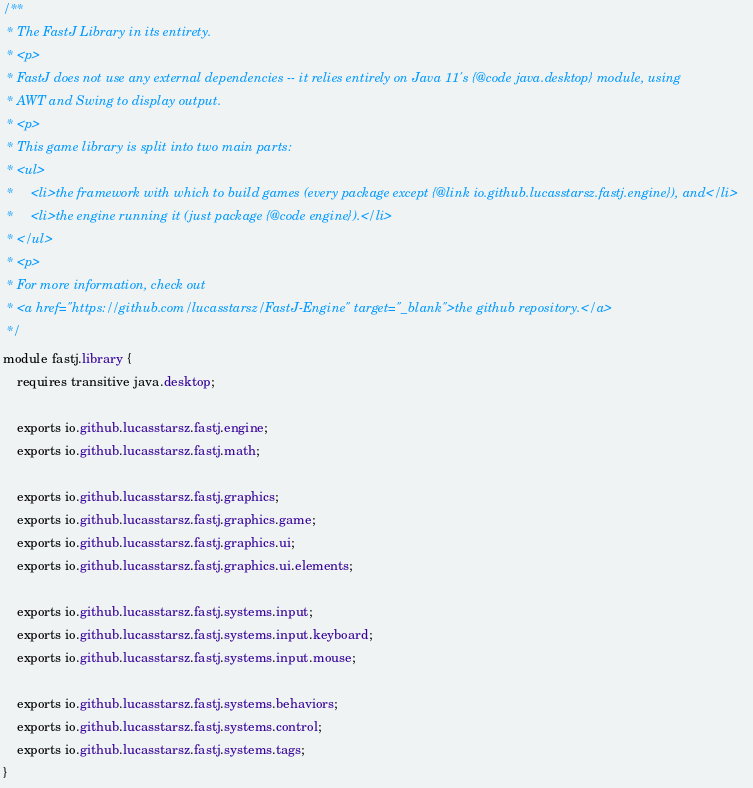<code> <loc_0><loc_0><loc_500><loc_500><_Java_>/**
 * The FastJ Library in its entirety.
 * <p>
 * FastJ does not use any external dependencies -- it relies entirely on Java 11's {@code java.desktop} module, using
 * AWT and Swing to display output.
 * <p>
 * This game library is split into two main parts:
 * <ul>
 *     <li>the framework with which to build games (every package except {@link io.github.lucasstarsz.fastj.engine}), and</li>
 *     <li>the engine running it (just package {@code engine}).</li>
 * </ul>
 * <p>
 * For more information, check out
 * <a href="https://github.com/lucasstarsz/FastJ-Engine" target="_blank">the github repository.</a>
 */
module fastj.library {
    requires transitive java.desktop;

    exports io.github.lucasstarsz.fastj.engine;
    exports io.github.lucasstarsz.fastj.math;

    exports io.github.lucasstarsz.fastj.graphics;
    exports io.github.lucasstarsz.fastj.graphics.game;
    exports io.github.lucasstarsz.fastj.graphics.ui;
    exports io.github.lucasstarsz.fastj.graphics.ui.elements;

    exports io.github.lucasstarsz.fastj.systems.input;
    exports io.github.lucasstarsz.fastj.systems.input.keyboard;
    exports io.github.lucasstarsz.fastj.systems.input.mouse;

    exports io.github.lucasstarsz.fastj.systems.behaviors;
    exports io.github.lucasstarsz.fastj.systems.control;
    exports io.github.lucasstarsz.fastj.systems.tags;
}
</code> 